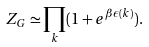Convert formula to latex. <formula><loc_0><loc_0><loc_500><loc_500>Z _ { G } \simeq \prod _ { k } ( 1 + e ^ { \beta \epsilon ( k ) } ) .</formula> 